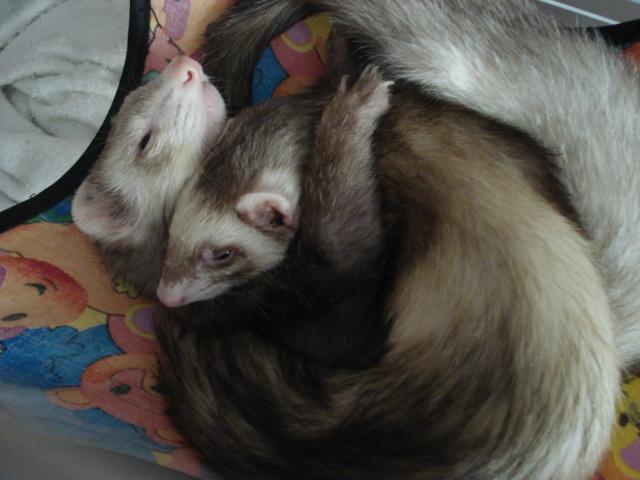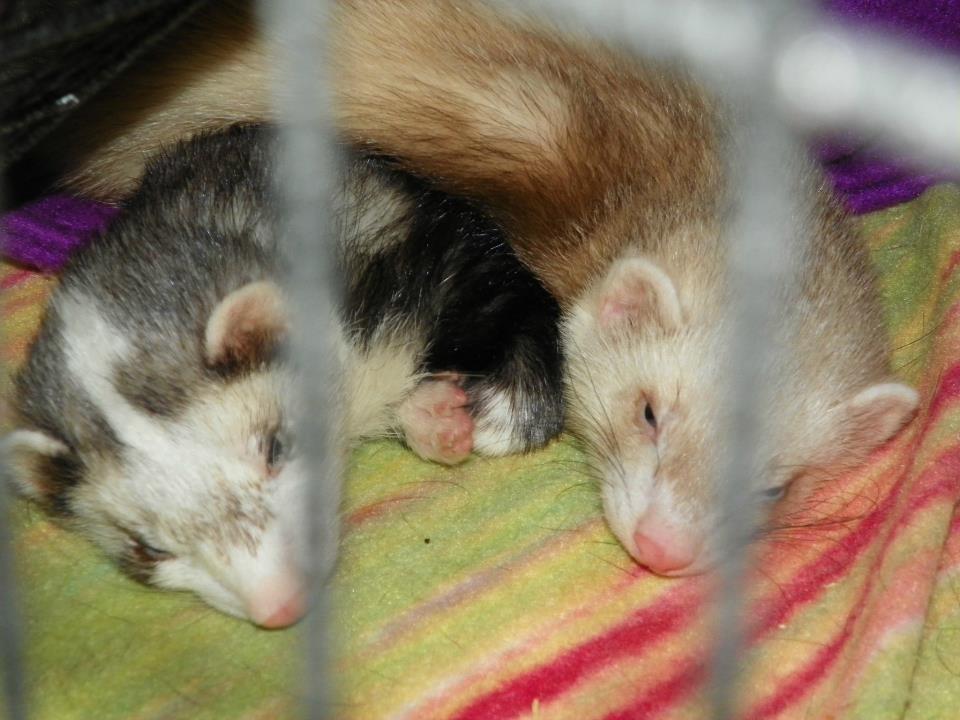The first image is the image on the left, the second image is the image on the right. Examine the images to the left and right. Is the description "Two ferrets are snuggled up together sleeping." accurate? Answer yes or no. Yes. The first image is the image on the left, the second image is the image on the right. Assess this claim about the two images: "There are exactly four ferrets.". Correct or not? Answer yes or no. Yes. 